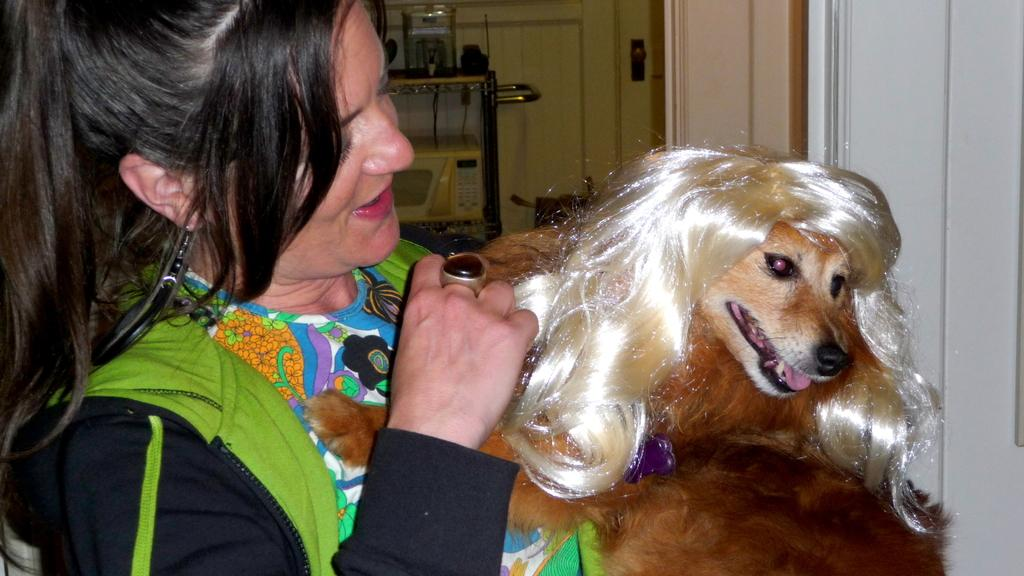Who is present in the image? There is a woman in the image. What type of animal is also present in the image? There is a dog in the image. What can be seen in the background of the image? There is a wall, an oven, and a door in the background of the image. What type of waste can be seen being disposed of in the image? There is no waste present in the image. How is the division of space being utilized in the image? The image does not depict any specific division of space; it simply shows a woman, a dog, and various objects in the background. 